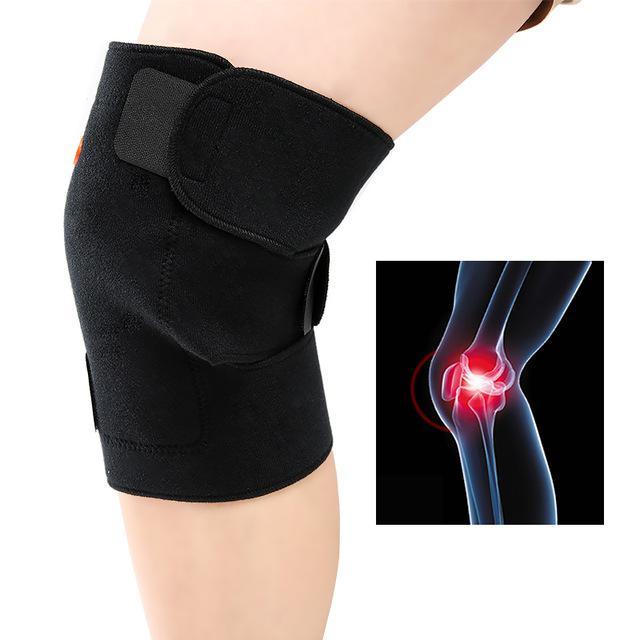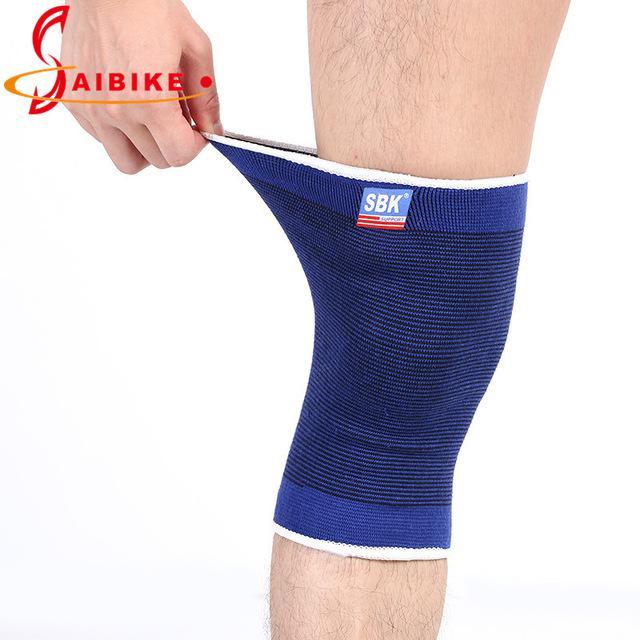The first image is the image on the left, the second image is the image on the right. Examine the images to the left and right. Is the description "The right image contains no more than one knee brace." accurate? Answer yes or no. Yes. The first image is the image on the left, the second image is the image on the right. Examine the images to the left and right. Is the description "There are exactly two knee braces." accurate? Answer yes or no. Yes. 